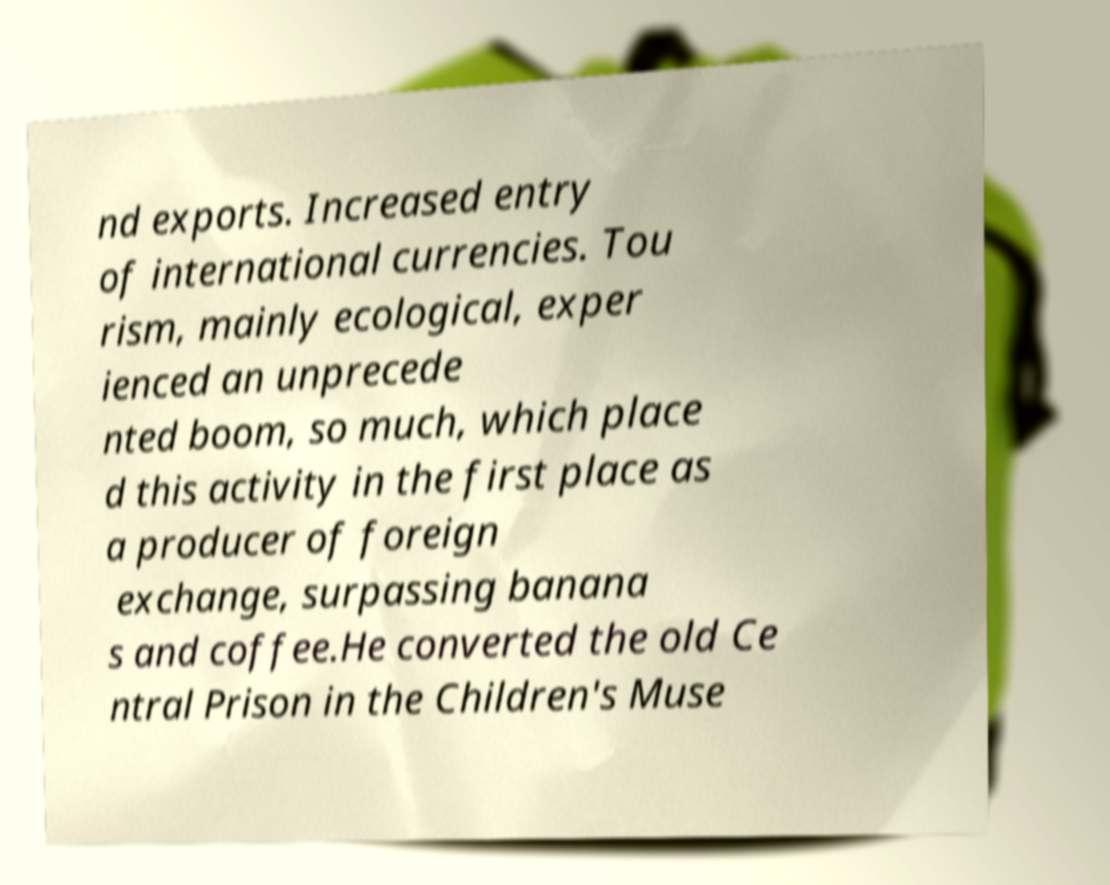Can you read and provide the text displayed in the image?This photo seems to have some interesting text. Can you extract and type it out for me? nd exports. Increased entry of international currencies. Tou rism, mainly ecological, exper ienced an unprecede nted boom, so much, which place d this activity in the first place as a producer of foreign exchange, surpassing banana s and coffee.He converted the old Ce ntral Prison in the Children's Muse 